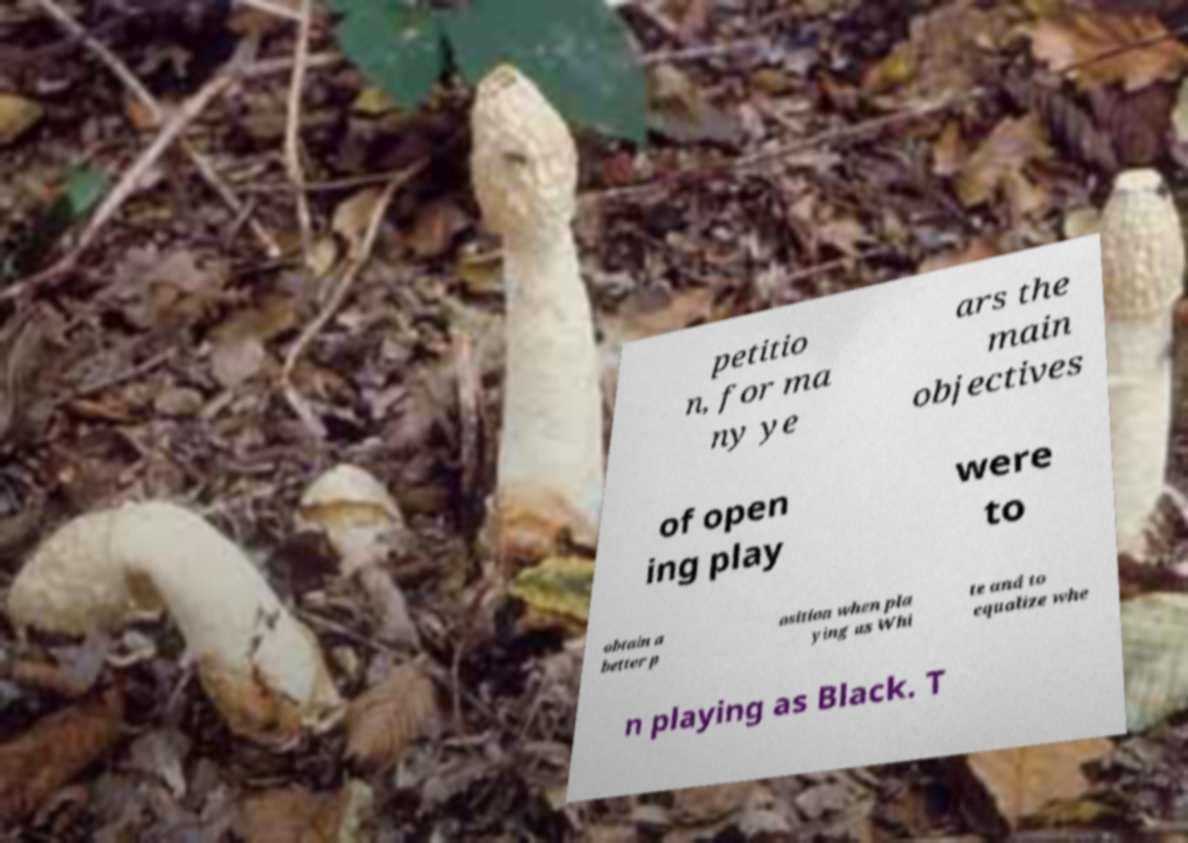Please read and relay the text visible in this image. What does it say? petitio n, for ma ny ye ars the main objectives of open ing play were to obtain a better p osition when pla ying as Whi te and to equalize whe n playing as Black. T 